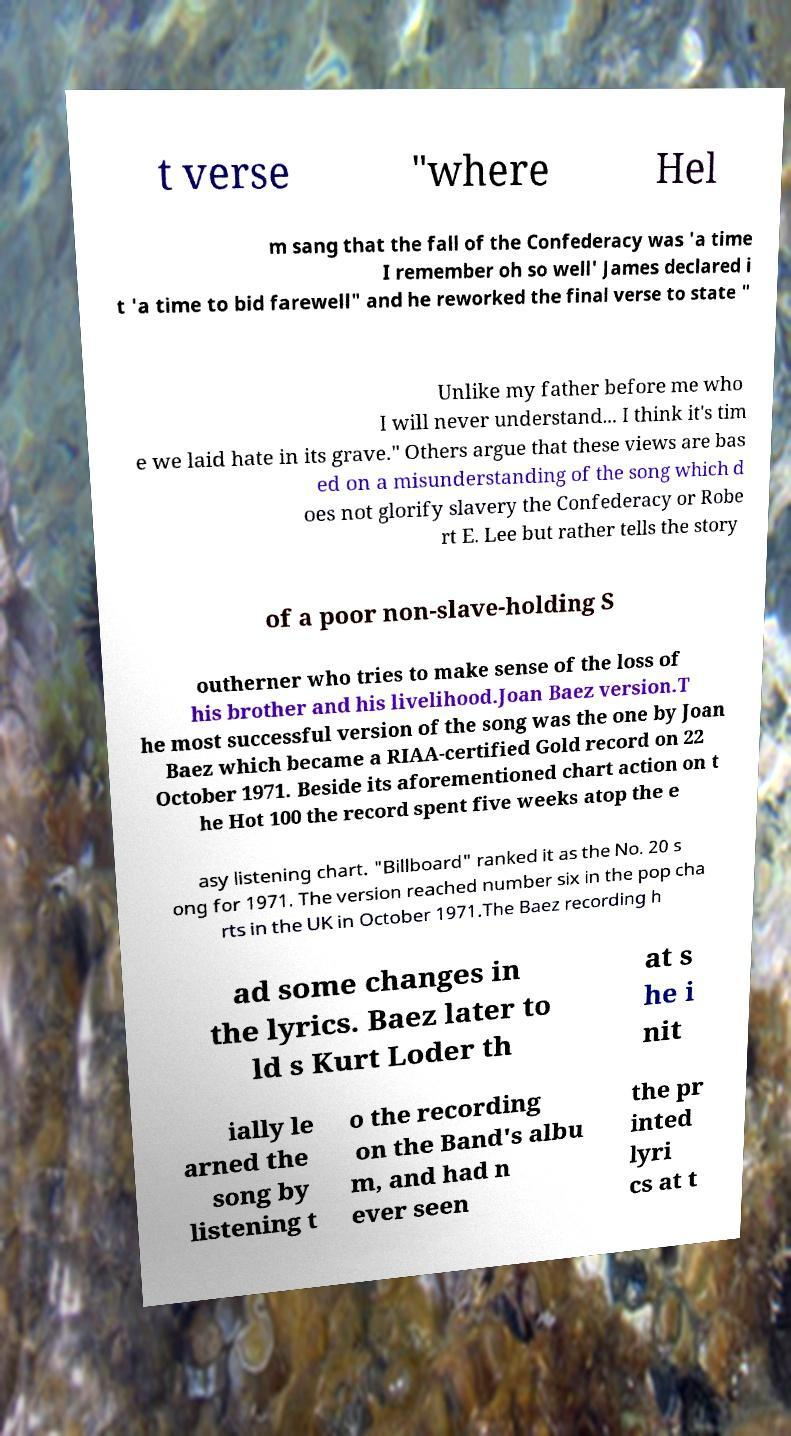Please identify and transcribe the text found in this image. t verse "where Hel m sang that the fall of the Confederacy was 'a time I remember oh so well' James declared i t 'a time to bid farewell" and he reworked the final verse to state " Unlike my father before me who I will never understand... I think it's tim e we laid hate in its grave." Others argue that these views are bas ed on a misunderstanding of the song which d oes not glorify slavery the Confederacy or Robe rt E. Lee but rather tells the story of a poor non-slave-holding S outherner who tries to make sense of the loss of his brother and his livelihood.Joan Baez version.T he most successful version of the song was the one by Joan Baez which became a RIAA-certified Gold record on 22 October 1971. Beside its aforementioned chart action on t he Hot 100 the record spent five weeks atop the e asy listening chart. "Billboard" ranked it as the No. 20 s ong for 1971. The version reached number six in the pop cha rts in the UK in October 1971.The Baez recording h ad some changes in the lyrics. Baez later to ld s Kurt Loder th at s he i nit ially le arned the song by listening t o the recording on the Band's albu m, and had n ever seen the pr inted lyri cs at t 